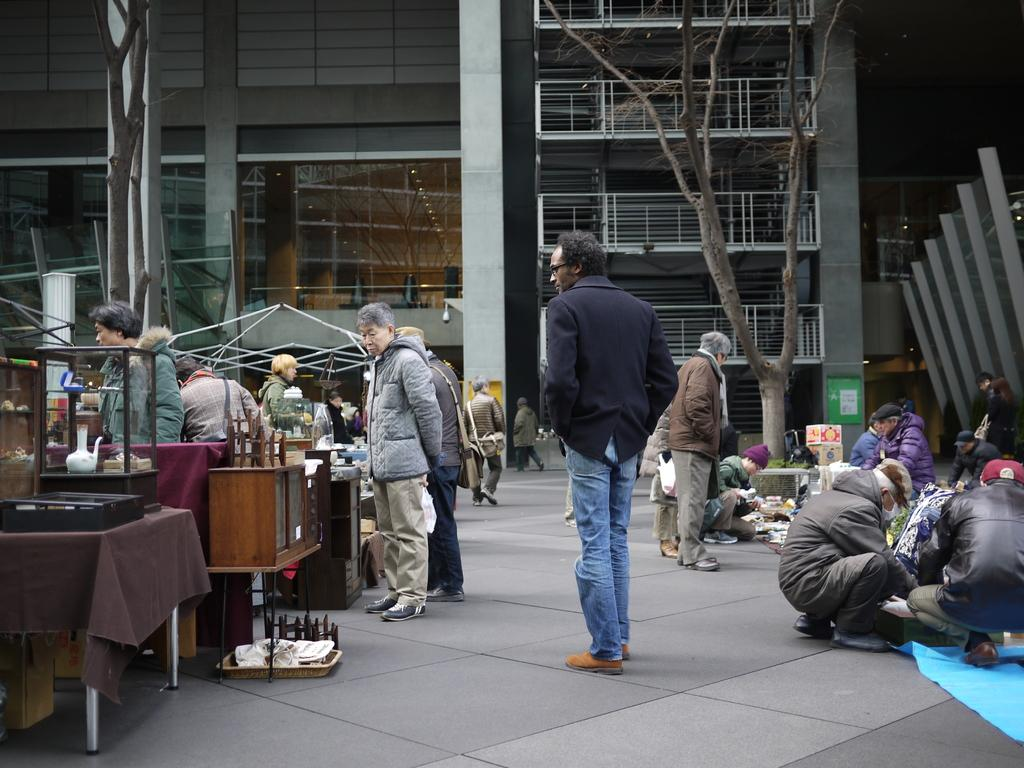What can be seen on the road in the image? There are people on the road in the image. What type of establishments are located on the left side of the road? There are small stores on the left side of the road. What are the people in the stores doing? People are selling items from the stores. What can be seen in the background of the image? There is a building and a tree in the background. What news is being discussed between the people in the image? There is no indication of any news being discussed in the image; it shows people on the road and in small stores. Can you describe the argument taking place between the man and the woman in the image? There is no man or woman arguing in the image; it shows people on the road and in small stores. 